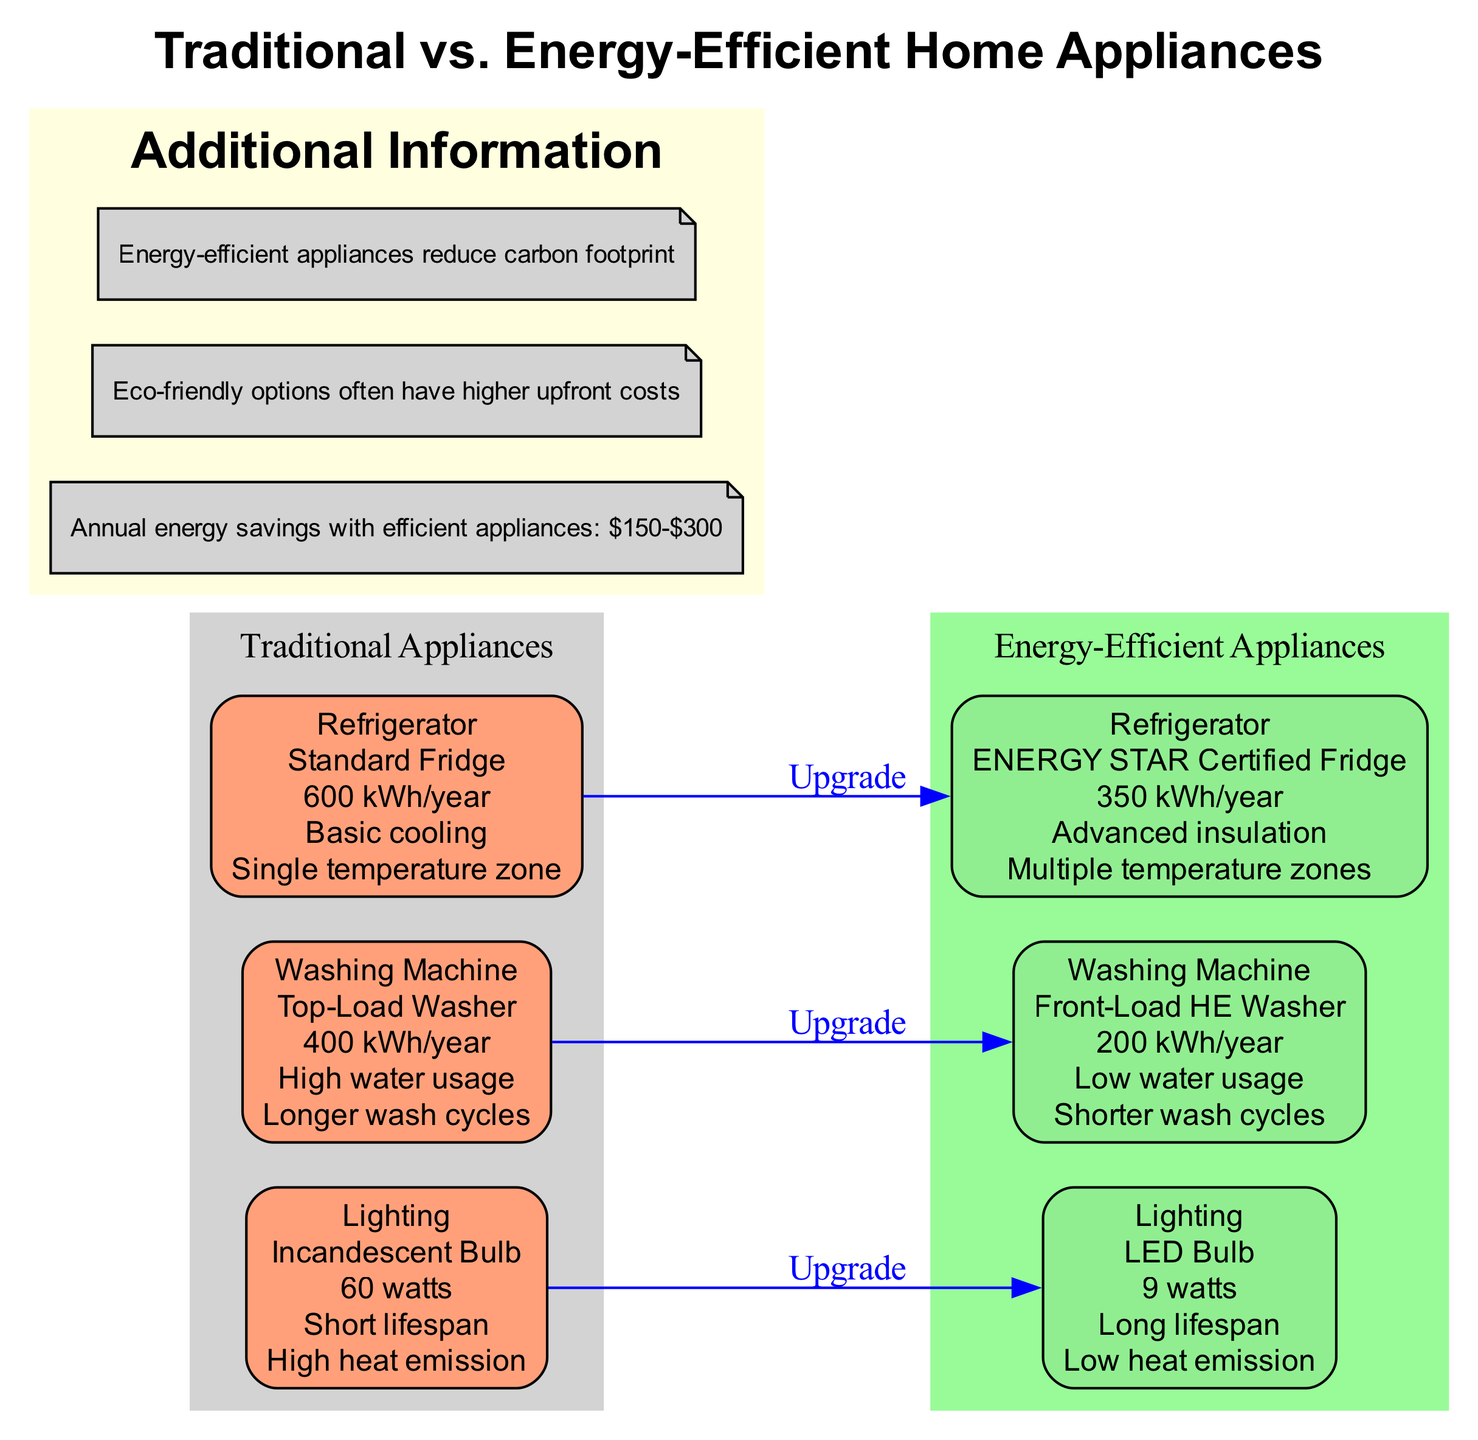What is the energy consumption of a traditional refrigerator? The traditional refrigerator shown in the diagram is a "Standard Fridge" with an energy consumption of "600 kWh/year," which is explicitly mentioned in the traditional appliances section.
Answer: 600 kWh/year What features does the energy-efficient washing machine provide? In the energy-efficient appliances section, the "Front-Load HE Washer" is listed, which has features such as "Low water usage" and "Shorter wash cycles" that provide a comparison to traditional options.
Answer: Low water usage, Shorter wash cycles What is the total number of appliance categories displayed in the diagram? The diagram presents three categories: Refrigerator, Washing Machine, and Lighting. By counting these categories in the diagram, we find there are three distinct types.
Answer: 3 How much energy does an LED bulb consume compared to an incandescent bulb? The diagram indicates that an "LED Bulb" consumes "9 watts," while an "Incandescent Bulb" consumes "60 watts." To find the difference, we compare these two values directly from the lighting section.
Answer: 51 watts Based on the information, how much can a consumer save annually by switching to energy-efficient appliances? The additional information section cites that annual energy savings with efficient appliances range between "$150-$300." This statement directly answers the annual savings potential from the diagram.
Answer: $150-$300 What is the model name of the traditional washing machine? In the traditional appliances section, the model for the washing machine category is specified as "Top-Load Washer," which indicates the standard type before considering energy-efficient alternatives.
Answer: Top-Load Washer Which appliance features advanced insulation? The diagram states that the "ENERGY STAR Certified Fridge" has features including "Advanced insulation," as part of the energy-efficient appliances segment, specifically for refrigerators.
Answer: Advanced insulation What color represents energy-efficient appliances in the diagram? The energy-efficient appliances are represented in the diagram using the color "palegreen," which is visually distinct and labeled under that section.
Answer: palegreen 